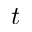<formula> <loc_0><loc_0><loc_500><loc_500>t</formula> 